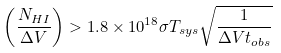<formula> <loc_0><loc_0><loc_500><loc_500>\left ( \frac { N _ { H I } } { \Delta V } \right ) > 1 . 8 \times 1 0 ^ { 1 8 } \sigma T _ { s y s } \sqrt { \frac { 1 } { \Delta V t _ { o b s } } }</formula> 